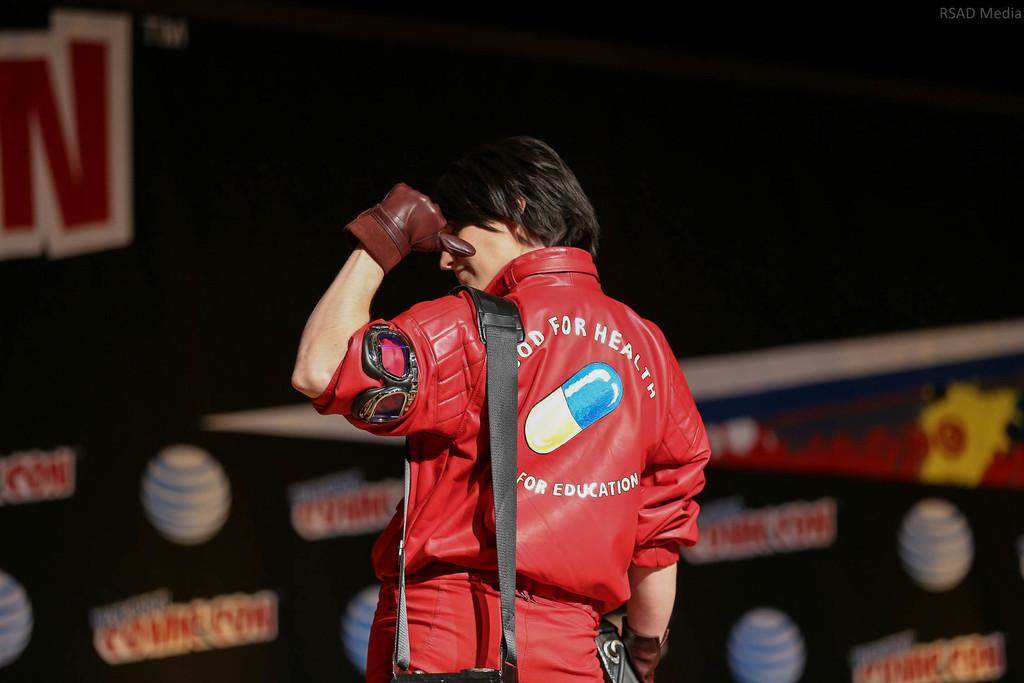<image>
Relay a brief, clear account of the picture shown. the word health that is on the back of a jacket 